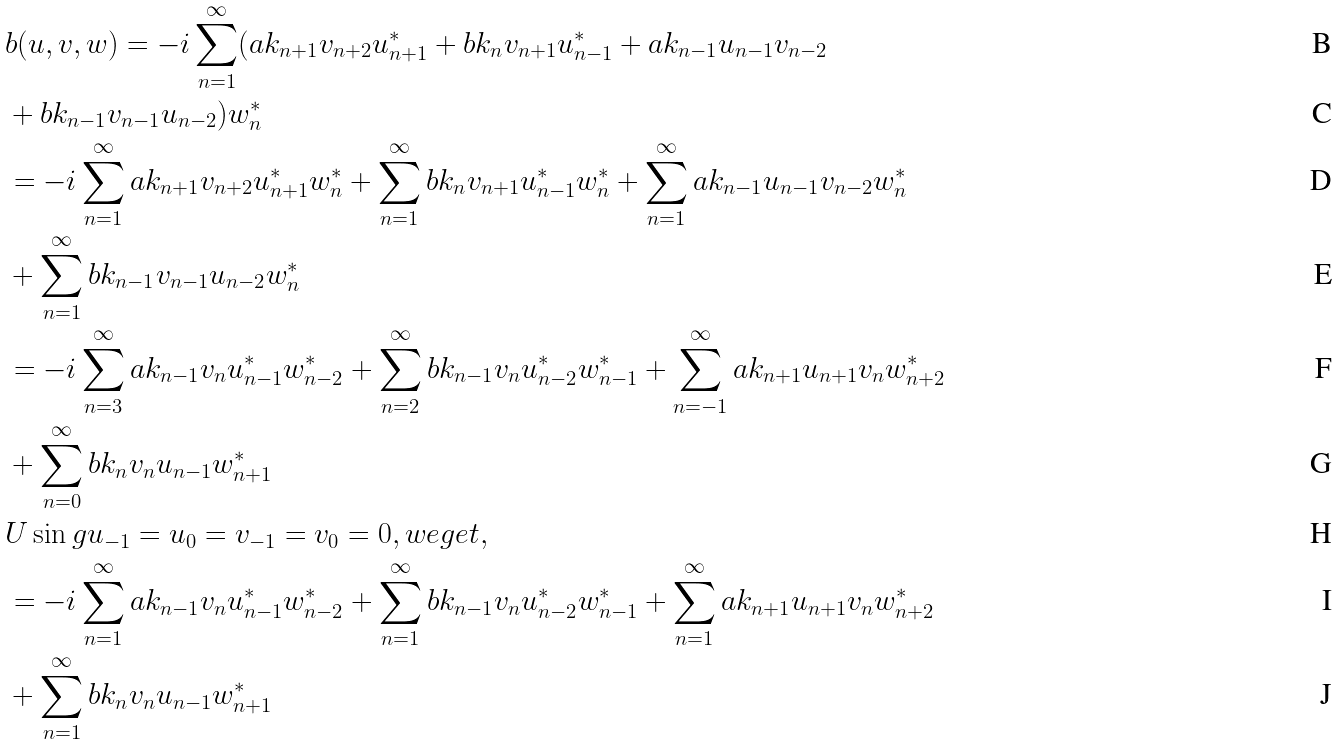Convert formula to latex. <formula><loc_0><loc_0><loc_500><loc_500>& b ( u , v , w ) = - i \sum _ { n = 1 } ^ { \infty } ( a k _ { n + 1 } v _ { n + 2 } u _ { n + 1 } ^ { * } + b k _ { n } v _ { n + 1 } u _ { n - 1 } ^ { * } + a k _ { n - 1 } u _ { n - 1 } v _ { n - 2 } \\ & + b k _ { n - 1 } v _ { n - 1 } u _ { n - 2 } ) w _ { n } ^ { * } \\ & = - i \sum _ { n = 1 } ^ { \infty } a k _ { n + 1 } v _ { n + 2 } u _ { n + 1 } ^ { * } w _ { n } ^ { * } + \sum _ { n = 1 } ^ { \infty } b k _ { n } v _ { n + 1 } u _ { n - 1 } ^ { * } w _ { n } ^ { * } + \sum _ { n = 1 } ^ { \infty } a k _ { n - 1 } u _ { n - 1 } v _ { n - 2 } w _ { n } ^ { * } \\ & + \sum _ { n = 1 } ^ { \infty } b k _ { n - 1 } v _ { n - 1 } u _ { n - 2 } w _ { n } ^ { * } \\ & = - i \sum _ { n = 3 } ^ { \infty } a k _ { n - 1 } v _ { n } u _ { n - 1 } ^ { * } w _ { n - 2 } ^ { * } + \sum _ { n = 2 } ^ { \infty } b k _ { n - 1 } v _ { n } u _ { n - 2 } ^ { * } w _ { n - 1 } ^ { * } + \sum _ { n = - 1 } ^ { \infty } a k _ { n + 1 } u _ { n + 1 } v _ { n } w _ { n + 2 } ^ { * } \\ & + \sum _ { n = 0 } ^ { \infty } b k _ { n } v _ { n } u _ { n - 1 } w _ { n + 1 } ^ { * } \\ & U \sin g u _ { - 1 } = u _ { 0 } = v _ { - 1 } = v _ { 0 } = 0 , w e g e t , \\ & = - i \sum _ { n = 1 } ^ { \infty } a k _ { n - 1 } v _ { n } u _ { n - 1 } ^ { * } w _ { n - 2 } ^ { * } + \sum _ { n = 1 } ^ { \infty } b k _ { n - 1 } v _ { n } u _ { n - 2 } ^ { * } w _ { n - 1 } ^ { * } + \sum _ { n = 1 } ^ { \infty } a k _ { n + 1 } u _ { n + 1 } v _ { n } w _ { n + 2 } ^ { * } \\ & + \sum _ { n = 1 } ^ { \infty } b k _ { n } v _ { n } u _ { n - 1 } w _ { n + 1 } ^ { * }</formula> 